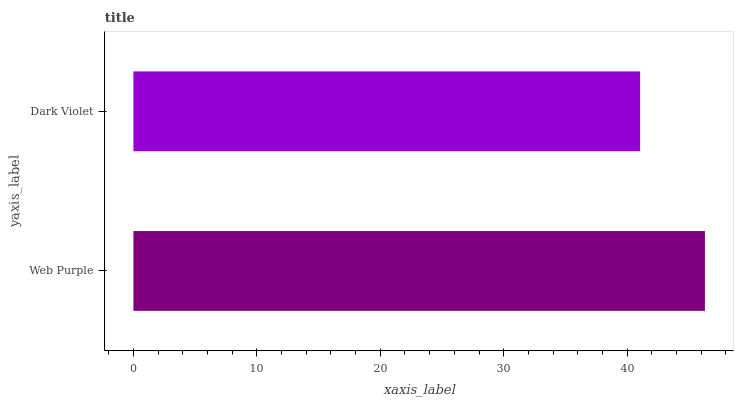Is Dark Violet the minimum?
Answer yes or no. Yes. Is Web Purple the maximum?
Answer yes or no. Yes. Is Dark Violet the maximum?
Answer yes or no. No. Is Web Purple greater than Dark Violet?
Answer yes or no. Yes. Is Dark Violet less than Web Purple?
Answer yes or no. Yes. Is Dark Violet greater than Web Purple?
Answer yes or no. No. Is Web Purple less than Dark Violet?
Answer yes or no. No. Is Web Purple the high median?
Answer yes or no. Yes. Is Dark Violet the low median?
Answer yes or no. Yes. Is Dark Violet the high median?
Answer yes or no. No. Is Web Purple the low median?
Answer yes or no. No. 